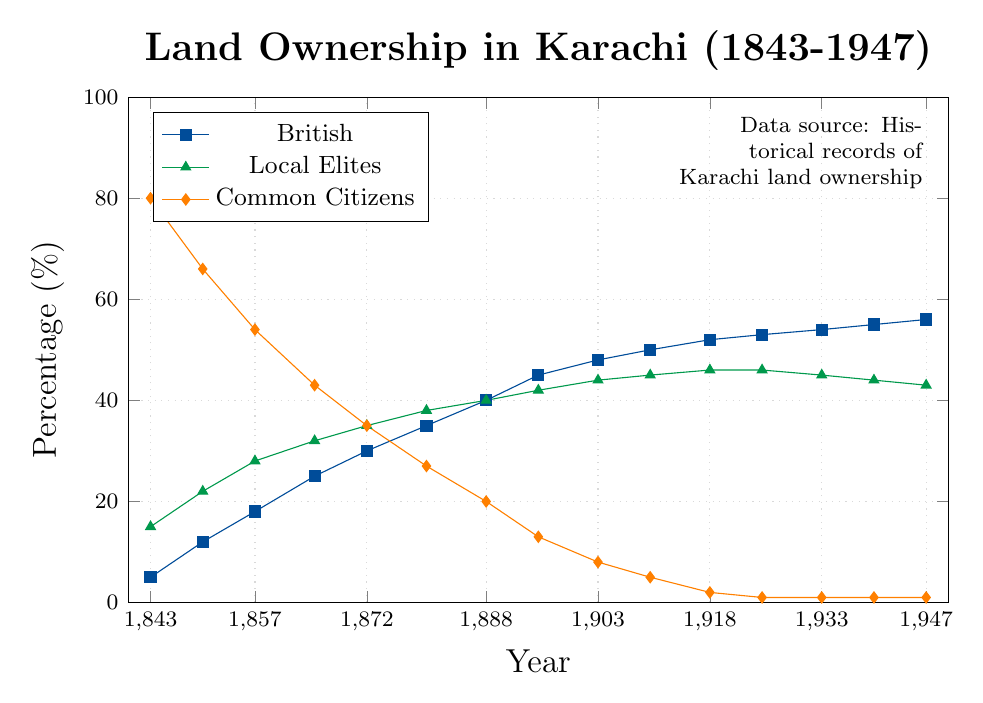Which group had the highest land ownership percentage in 1843? In 1843, the land ownership percentages were 5% for the British, 15% for local elites, and 80% for common citizens. The highest percentage is 80% for common citizens.
Answer: Common citizens By how many percentage points did British land ownership increase from 1843 to 1850? In 1843, British land ownership was 5%, and it increased to 12% in 1850. The difference is 12% - 5% = 7%.
Answer: 7 In which year did land ownership percentage by local elites peak, and what was the percentage? The local elites' land ownership percentage peaked at 46% in the years 1918 and 1925.
Answer: 1918 and 1925, 46% Compare the trend of land ownership for the British and common citizens from 1843 to 1947. What do you observe? The British land ownership percentage increased gradually from 5% in 1843 to 56% in 1947. Conversely, common citizens' land ownership percentage decreased sharply from 80% in 1843 to 1% by 1947. This indicates a transfer of land ownership from common citizens to the British over time.
Answer: British increased, common citizens decreased Which group had the most stable land ownership percentage during the period, and what does this suggest? The British had a steadily increasing trend, whereas local elites and common citizens showed fluctuations. Local elites had comparatively more stable percentages, peaking at 46% and then slightly decreasing to 43%. This suggests local elites maintained a significant but relatively stable share of land ownership.
Answer: Local elites What was the percentage decrease in common citizens’ land ownership from 1843 to 1947? In 1843, common citizens' land ownership was 80%, and it decreased to 1% in 1947. The percentage decrease is 80% - 1% = 79%.
Answer: 79 Between what years did British land ownership surpass 50%? British land ownership surpassed 50% between the years 1910 (50%) and 1918 (52%).
Answer: Between 1910 and 1918 What was the difference in land ownership percentages between British and local elites in 1933? In 1933, the British had 54% land ownership, while local elites had 45%. The difference is 54% - 45% = 9%.
Answer: 9 How did the trend in land ownership for local elites change after 1925? Local elites' land ownership percentage peaked at 46% in 1925, then slightly decreased to 43% by 1947. This shows a minor decline after hitting a peak.
Answer: Slight decrease Calculate the average land ownership percentage for common citizens over the entire period. The percentages for common citizens are: 80, 66, 54, 43, 35, 27, 20, 13, 8, 5, 2, 1, 1, 1, 1. Summing these values gives 357. There are 15 data points, so the average is 357 / 15 ≈ 23.8%.
Answer: 23.8 